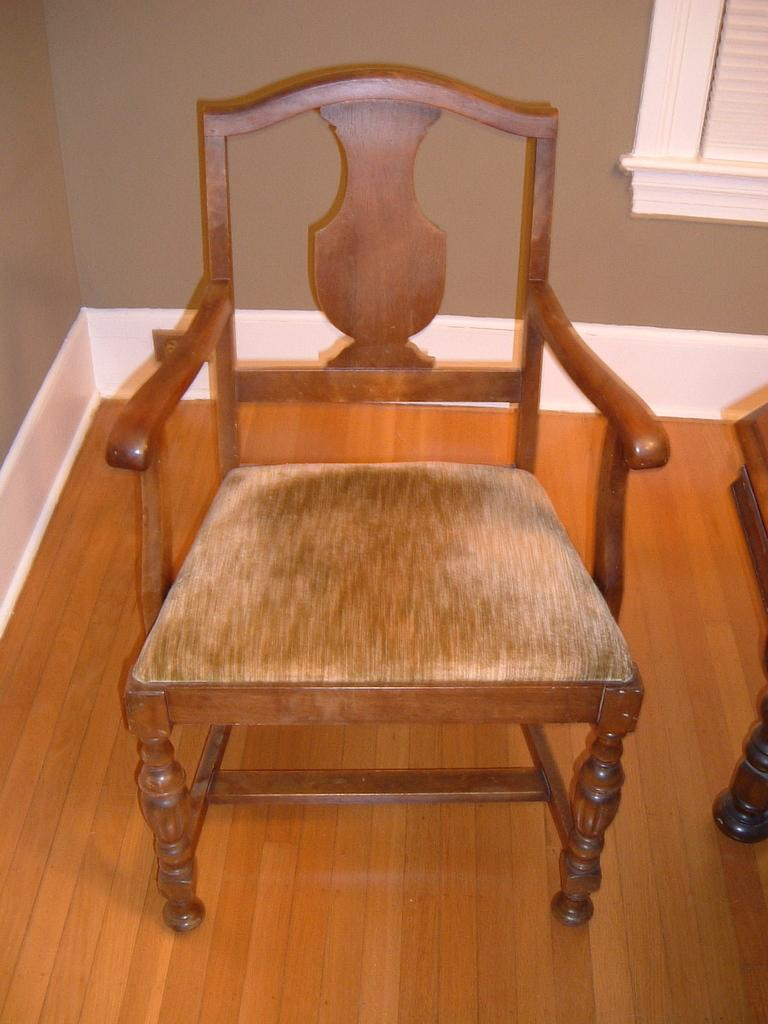What type of furniture is visible in the image? There is a chair in the image. Where is the chair located in relation to the image? The chair is at the front of the image. What type of structure is present in the image? There is a wall in the image. Where is the wall located in relation to the image? The wall is at the back side of the image. What type of fruit is being used to oil the chair in the image? There is no fruit or oiling activity present in the image; it only features a chair and a wall. 